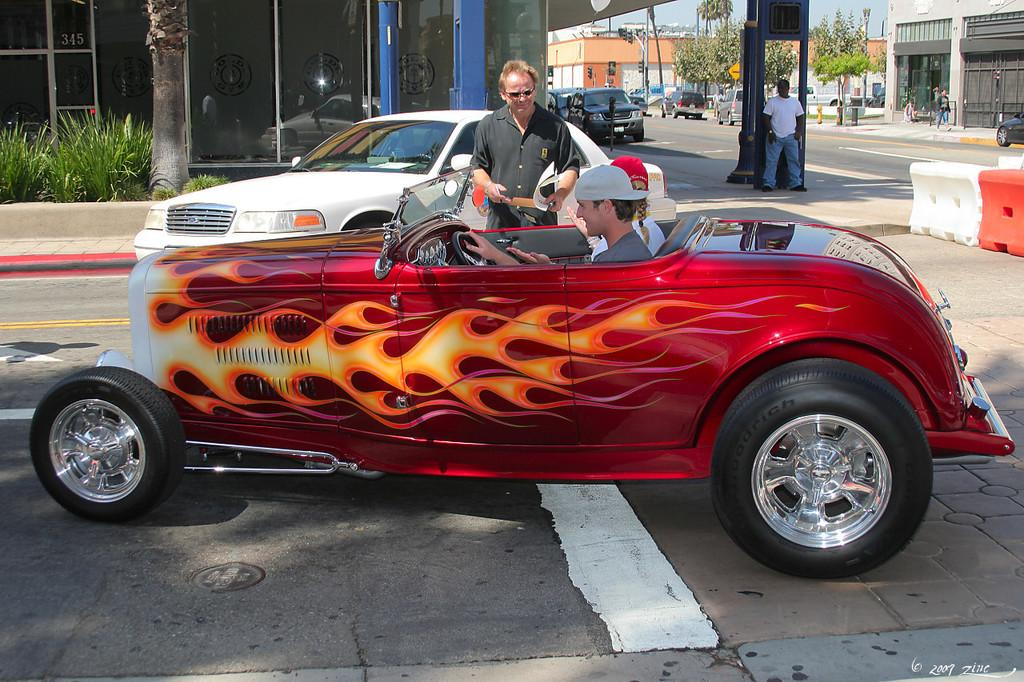What are the two persons in the car doing? The two persons are sitting in a car. What can be seen in the background of the image? There is a building and a tree in the background of the image. What is happening on the road in the image? There are two persons standing on the road. What type of profit can be seen being generated by the cattle in the image? There are no cattle present in the image, so there is no profit being generated. Where is the playground located in the image? There is no playground present in the image. 